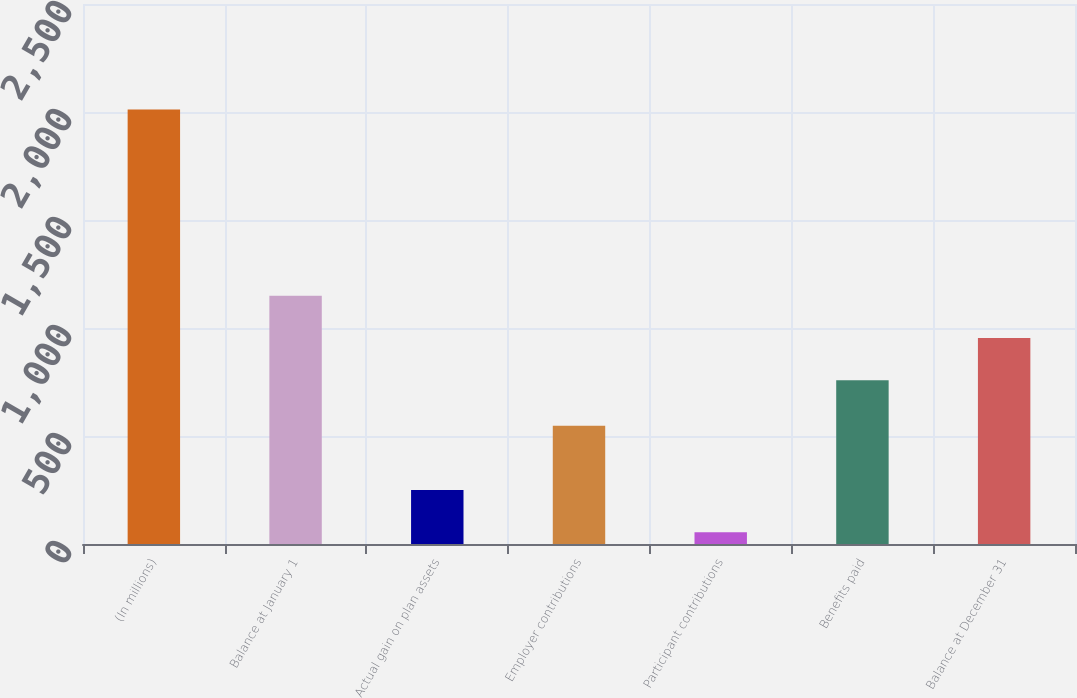Convert chart to OTSL. <chart><loc_0><loc_0><loc_500><loc_500><bar_chart><fcel>(In millions)<fcel>Balance at January 1<fcel>Actual gain on plan assets<fcel>Employer contributions<fcel>Participant contributions<fcel>Benefits paid<fcel>Balance at December 31<nl><fcel>2012<fcel>1149.6<fcel>249.8<fcel>548<fcel>54<fcel>758<fcel>953.8<nl></chart> 